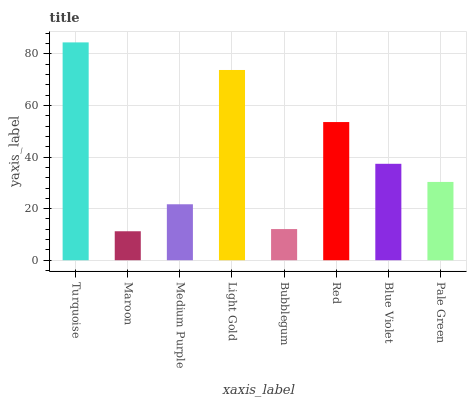Is Maroon the minimum?
Answer yes or no. Yes. Is Turquoise the maximum?
Answer yes or no. Yes. Is Medium Purple the minimum?
Answer yes or no. No. Is Medium Purple the maximum?
Answer yes or no. No. Is Medium Purple greater than Maroon?
Answer yes or no. Yes. Is Maroon less than Medium Purple?
Answer yes or no. Yes. Is Maroon greater than Medium Purple?
Answer yes or no. No. Is Medium Purple less than Maroon?
Answer yes or no. No. Is Blue Violet the high median?
Answer yes or no. Yes. Is Pale Green the low median?
Answer yes or no. Yes. Is Maroon the high median?
Answer yes or no. No. Is Bubblegum the low median?
Answer yes or no. No. 